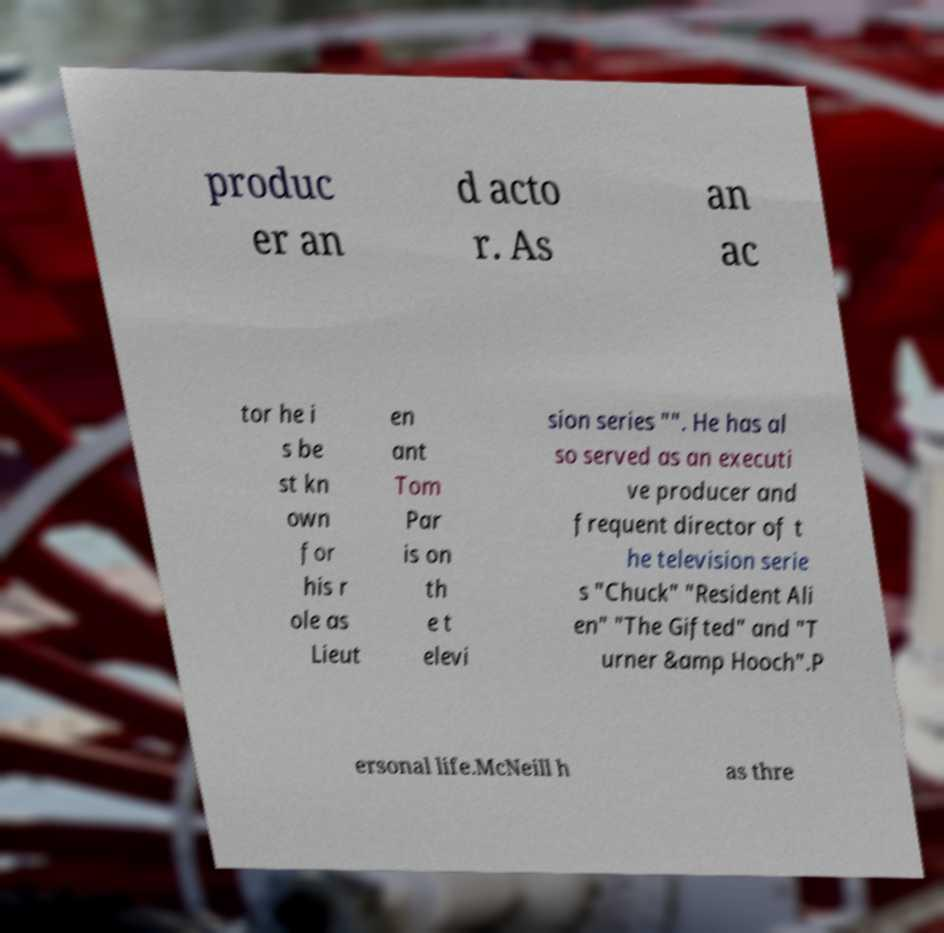There's text embedded in this image that I need extracted. Can you transcribe it verbatim? produc er an d acto r. As an ac tor he i s be st kn own for his r ole as Lieut en ant Tom Par is on th e t elevi sion series "". He has al so served as an executi ve producer and frequent director of t he television serie s "Chuck" "Resident Ali en" "The Gifted" and "T urner &amp Hooch".P ersonal life.McNeill h as thre 